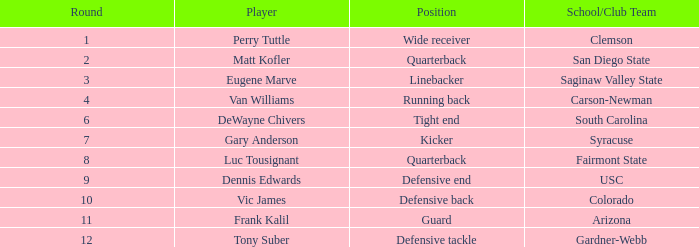Which player's pick is 160? DeWayne Chivers. 